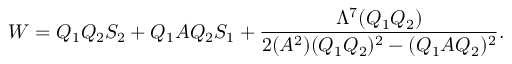Convert formula to latex. <formula><loc_0><loc_0><loc_500><loc_500>W = Q _ { 1 } Q _ { 2 } S _ { 2 } + Q _ { 1 } A Q _ { 2 } S _ { 1 } + \frac { \Lambda ^ { 7 } ( Q _ { 1 } Q _ { 2 } ) } { 2 ( A ^ { 2 } ) ( Q _ { 1 } Q _ { 2 } ) ^ { 2 } - ( Q _ { 1 } A Q _ { 2 } ) ^ { 2 } } .</formula> 